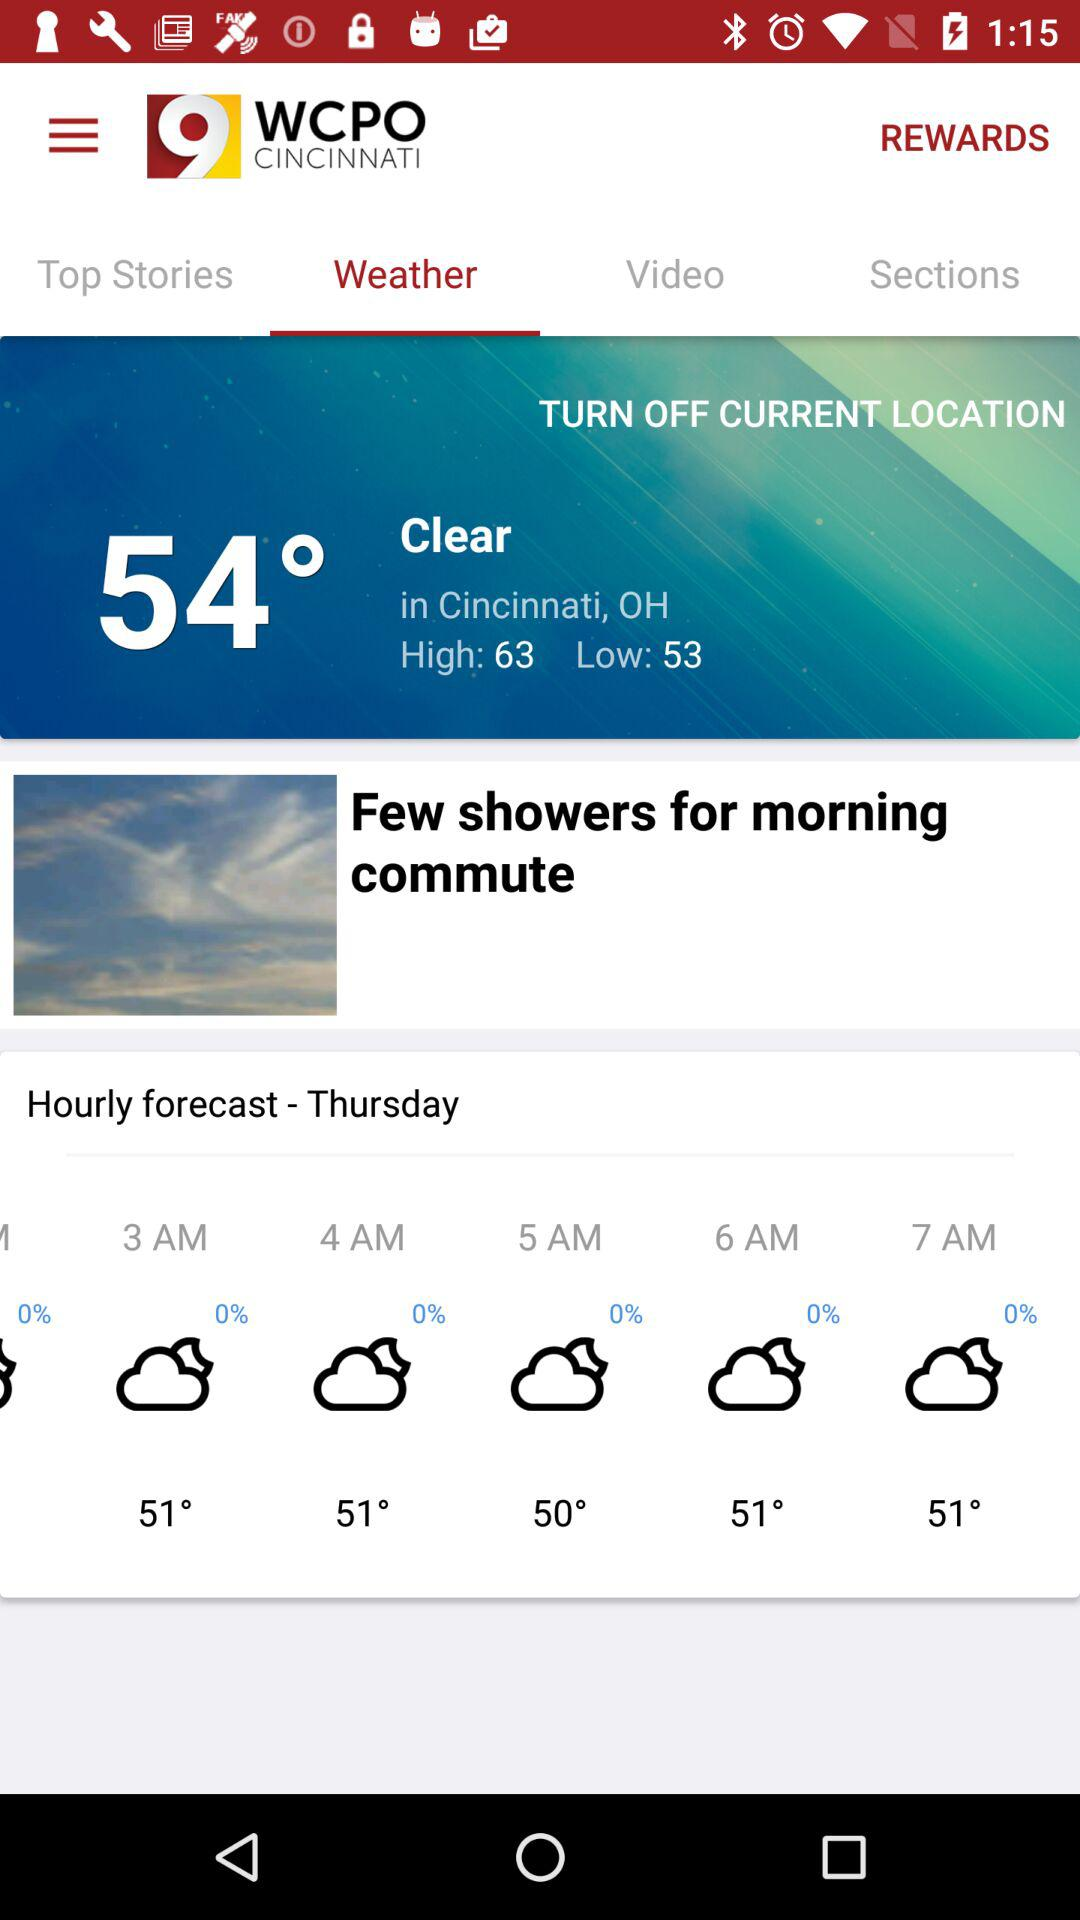What's the temperature at 4 AM Thursday? The temperature is 51°. 